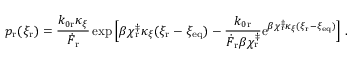<formula> <loc_0><loc_0><loc_500><loc_500>p _ { r } ( \xi _ { r } ) = \frac { k _ { 0 r } \kappa _ { \xi } } { \dot { F } _ { r } } \exp { \left [ \beta \chi _ { r } ^ { \ddag } \kappa _ { \xi } ( \xi _ { r } - \xi _ { e q } ) - \frac { k _ { 0 r } } { \dot { F } _ { r } \beta \chi _ { r } ^ { \ddag } } e ^ { \beta \chi _ { r } ^ { \ddag } \kappa _ { \xi } ( \xi _ { r } - \xi _ { e q } ) } \right ] } .</formula> 